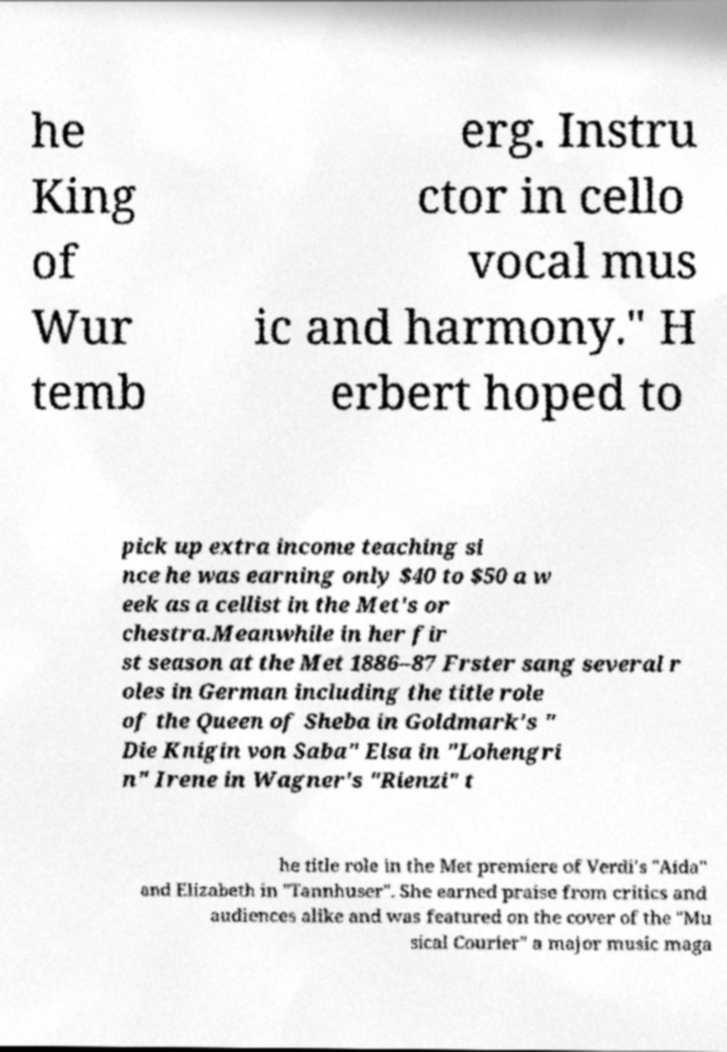Can you read and provide the text displayed in the image?This photo seems to have some interesting text. Can you extract and type it out for me? he King of Wur temb erg. Instru ctor in cello vocal mus ic and harmony." H erbert hoped to pick up extra income teaching si nce he was earning only $40 to $50 a w eek as a cellist in the Met's or chestra.Meanwhile in her fir st season at the Met 1886–87 Frster sang several r oles in German including the title role of the Queen of Sheba in Goldmark's " Die Knigin von Saba" Elsa in "Lohengri n" Irene in Wagner's "Rienzi" t he title role in the Met premiere of Verdi's "Aida" and Elizabeth in "Tannhuser". She earned praise from critics and audiences alike and was featured on the cover of the "Mu sical Courier" a major music maga 